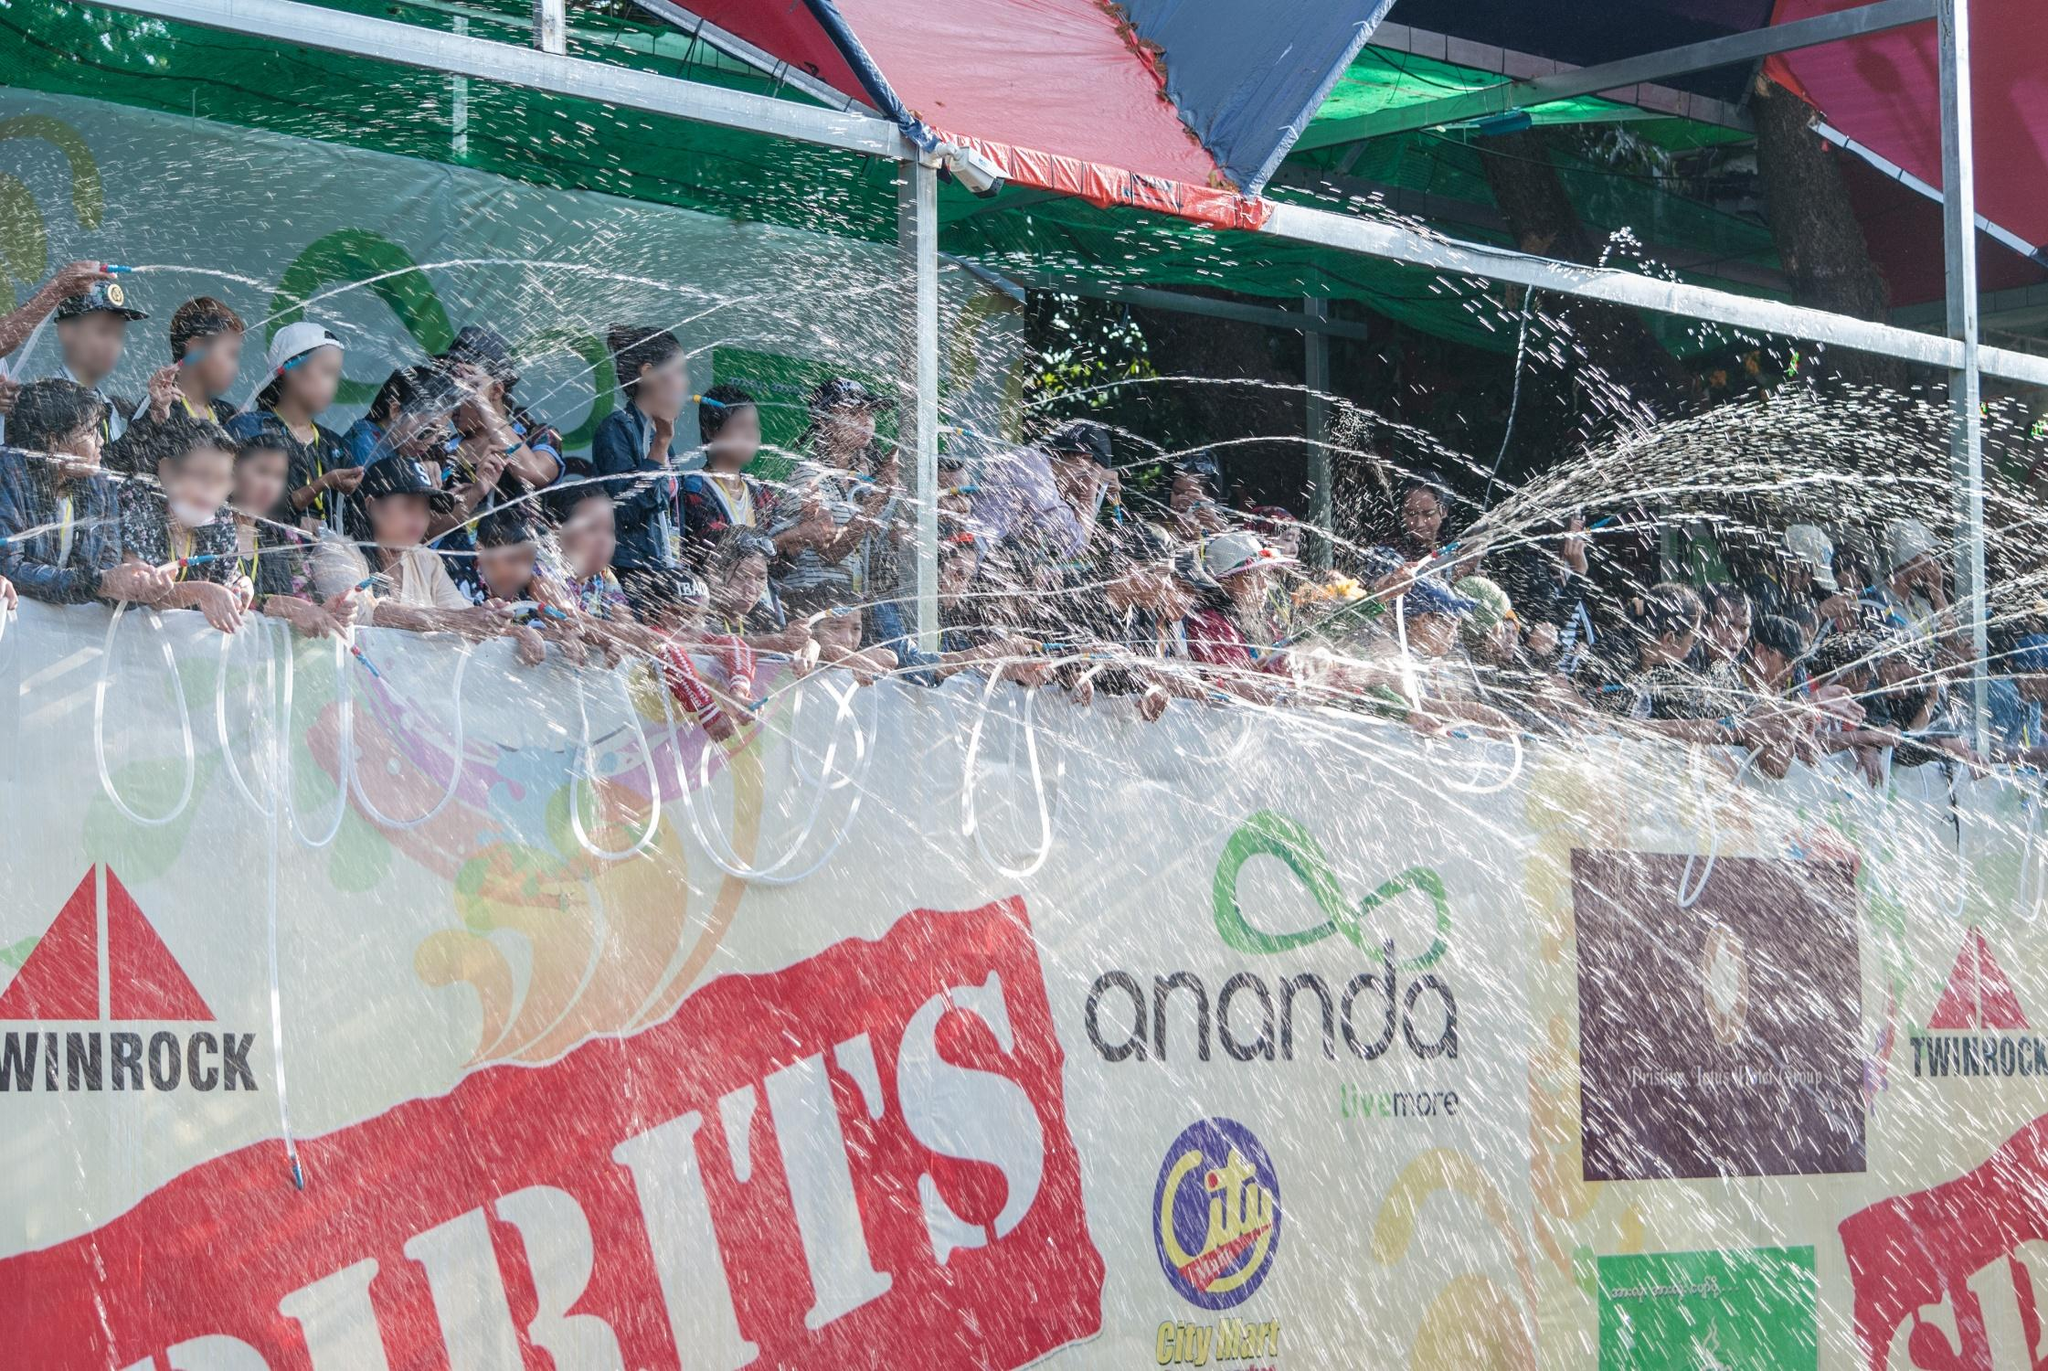What might be the occasion for this festivity? Judging by the enthusiastic water fight and the colorful decorations on the float, this celebration could be part of a traditional water festival. In various cultures, such as in Thailand's Songkran or Myanmar’s Thingyan, water festivals are celebrated with great joy, marking the New Year or the coming of the rainy season. These festivals often involve communal activities where people splash water on each other, symbolizing purification and the washing away of bad luck and sins. The lively and joyous atmosphere captured in the image certainly aligns with the spirit of such water festivals. 